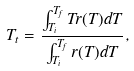Convert formula to latex. <formula><loc_0><loc_0><loc_500><loc_500>T _ { t } = \frac { \int _ { T _ { i } } ^ { T _ { f } } T r ( T ) d T } { \int _ { T _ { i } } ^ { T _ { f } } r ( T ) d T } ,</formula> 